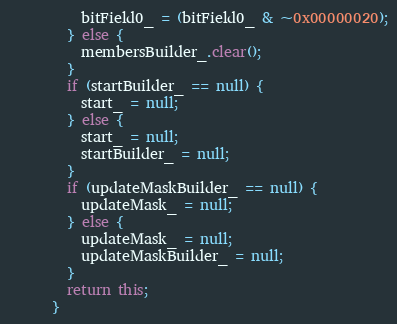Convert code to text. <code><loc_0><loc_0><loc_500><loc_500><_Java_>          bitField0_ = (bitField0_ & ~0x00000020);
        } else {
          membersBuilder_.clear();
        }
        if (startBuilder_ == null) {
          start_ = null;
        } else {
          start_ = null;
          startBuilder_ = null;
        }
        if (updateMaskBuilder_ == null) {
          updateMask_ = null;
        } else {
          updateMask_ = null;
          updateMaskBuilder_ = null;
        }
        return this;
      }
</code> 